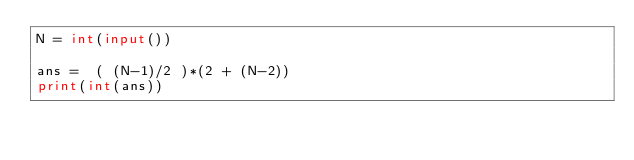<code> <loc_0><loc_0><loc_500><loc_500><_Python_>N = int(input())

ans =  ( (N-1)/2 )*(2 + (N-2))
print(int(ans))
</code> 